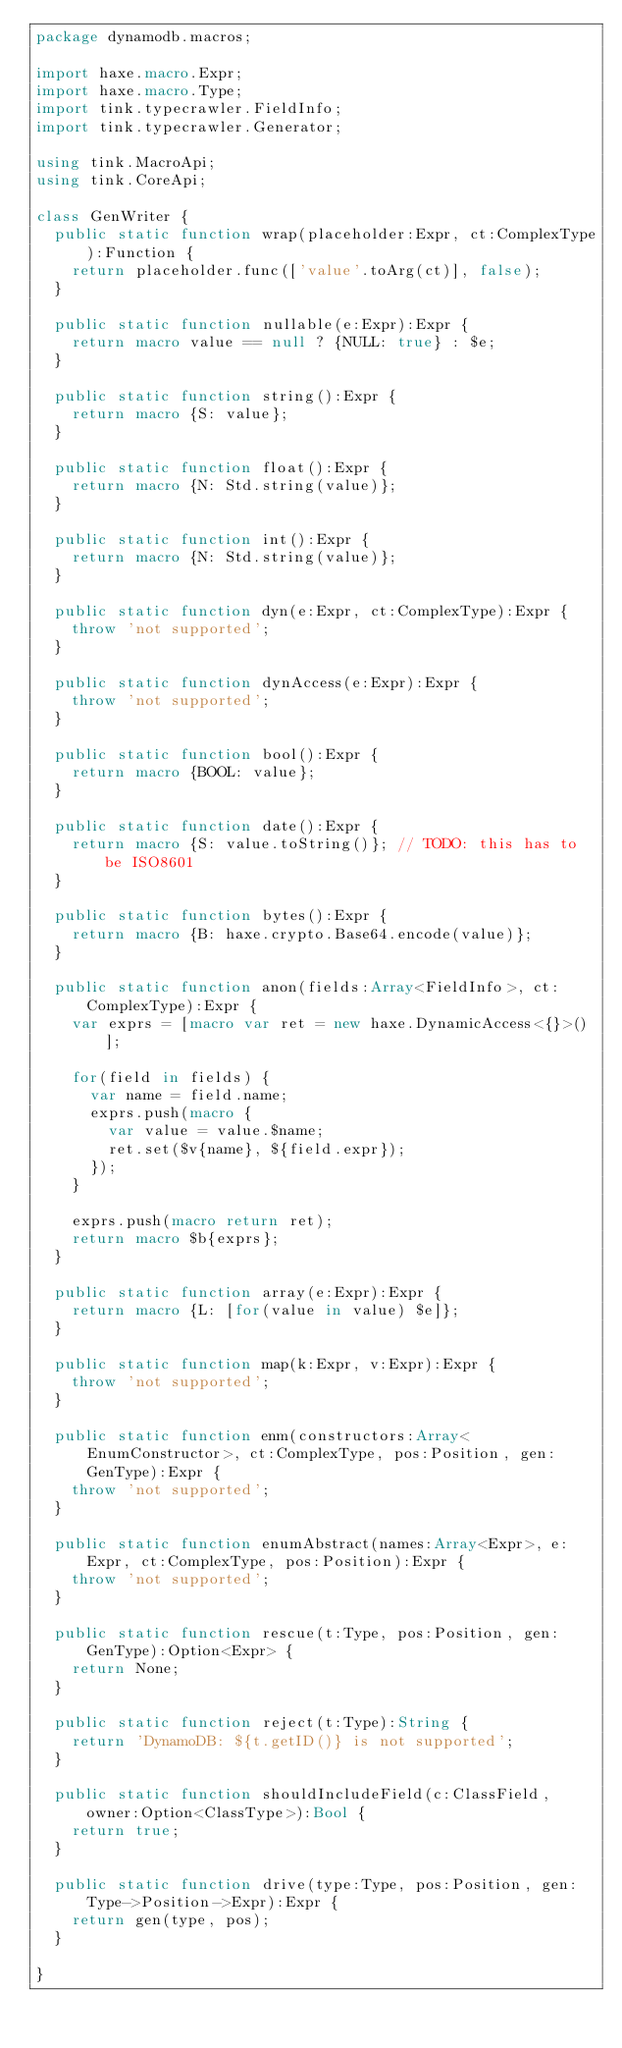Convert code to text. <code><loc_0><loc_0><loc_500><loc_500><_Haxe_>package dynamodb.macros;

import haxe.macro.Expr;
import haxe.macro.Type;
import tink.typecrawler.FieldInfo;
import tink.typecrawler.Generator;

using tink.MacroApi;
using tink.CoreApi;

class GenWriter {
	public static function wrap(placeholder:Expr, ct:ComplexType):Function {
		return placeholder.func(['value'.toArg(ct)], false);
	}
	
	public static function nullable(e:Expr):Expr {
		return macro value == null ? {NULL: true} : $e;
	}
	
	public static function string():Expr {
		return macro {S: value};
	}
	
	public static function float():Expr {
		return macro {N: Std.string(value)};
	}
	
	public static function int():Expr {
		return macro {N: Std.string(value)};
	}
	
	public static function dyn(e:Expr, ct:ComplexType):Expr {
		throw 'not supported';
	}
	
	public static function dynAccess(e:Expr):Expr {
		throw 'not supported';
	}
	
	public static function bool():Expr {
		return macro {BOOL: value};
	}
	
	public static function date():Expr {
		return macro {S: value.toString()}; // TODO: this has to be ISO8601
	}
	
	public static function bytes():Expr {
		return macro {B: haxe.crypto.Base64.encode(value)};
	}
	
	public static function anon(fields:Array<FieldInfo>, ct:ComplexType):Expr {
		var exprs = [macro var ret = new haxe.DynamicAccess<{}>()];
		
		for(field in fields) {
			var name = field.name;
			exprs.push(macro {
				var value = value.$name;
				ret.set($v{name}, ${field.expr});
			});
		}
		
		exprs.push(macro return ret);
		return macro $b{exprs};
	}
	
	public static function array(e:Expr):Expr {
		return macro {L: [for(value in value) $e]};
	}
	
	public static function map(k:Expr, v:Expr):Expr {
		throw 'not supported';
	}
	
	public static function enm(constructors:Array<EnumConstructor>, ct:ComplexType, pos:Position, gen:GenType):Expr {
		throw 'not supported';
	}
	
	public static function enumAbstract(names:Array<Expr>, e:Expr, ct:ComplexType, pos:Position):Expr {
		throw 'not supported';
	}
	
	public static function rescue(t:Type, pos:Position, gen:GenType):Option<Expr> {
		return None;
	}
	
	public static function reject(t:Type):String {
		return 'DynamoDB: ${t.getID()} is not supported';
	}
	
	public static function shouldIncludeField(c:ClassField, owner:Option<ClassType>):Bool {
		return true;
	}
	
	public static function drive(type:Type, pos:Position, gen:Type->Position->Expr):Expr {
		return gen(type, pos);
	}
	
}</code> 